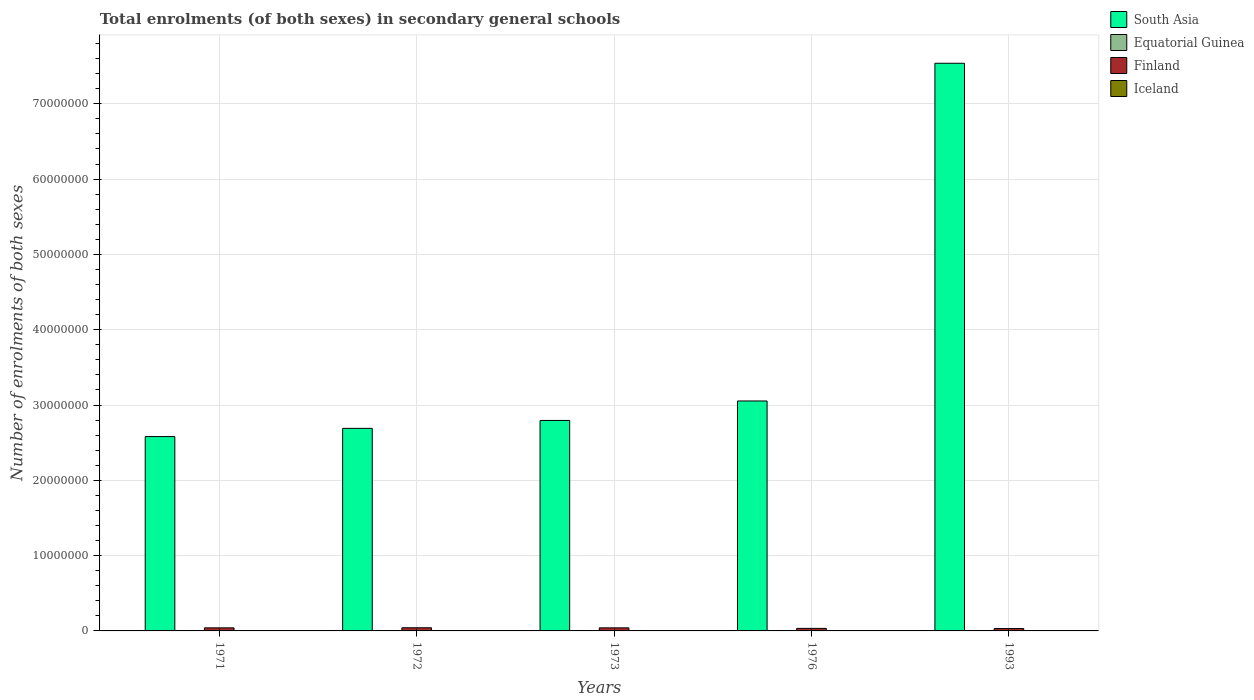How many different coloured bars are there?
Make the answer very short. 4. How many groups of bars are there?
Ensure brevity in your answer.  5. Are the number of bars on each tick of the X-axis equal?
Your response must be concise. Yes. How many bars are there on the 4th tick from the left?
Your response must be concise. 4. How many bars are there on the 2nd tick from the right?
Give a very brief answer. 4. What is the label of the 5th group of bars from the left?
Your answer should be very brief. 1993. What is the number of enrolments in secondary schools in Finland in 1972?
Ensure brevity in your answer.  4.18e+05. Across all years, what is the maximum number of enrolments in secondary schools in Equatorial Guinea?
Offer a terse response. 1.52e+04. Across all years, what is the minimum number of enrolments in secondary schools in Equatorial Guinea?
Give a very brief answer. 3984. What is the total number of enrolments in secondary schools in Finland in the graph?
Provide a succinct answer. 1.89e+06. What is the difference between the number of enrolments in secondary schools in Equatorial Guinea in 1972 and that in 1973?
Offer a very short reply. 188. What is the difference between the number of enrolments in secondary schools in Equatorial Guinea in 1973 and the number of enrolments in secondary schools in Iceland in 1976?
Offer a terse response. -1.56e+04. What is the average number of enrolments in secondary schools in Finland per year?
Provide a succinct answer. 3.77e+05. In the year 1971, what is the difference between the number of enrolments in secondary schools in South Asia and number of enrolments in secondary schools in Iceland?
Ensure brevity in your answer.  2.58e+07. In how many years, is the number of enrolments in secondary schools in Iceland greater than 30000000?
Make the answer very short. 0. What is the ratio of the number of enrolments in secondary schools in Equatorial Guinea in 1976 to that in 1993?
Your answer should be very brief. 0.26. Is the number of enrolments in secondary schools in Equatorial Guinea in 1971 less than that in 1973?
Your answer should be very brief. No. What is the difference between the highest and the second highest number of enrolments in secondary schools in Iceland?
Your answer should be very brief. 4076. What is the difference between the highest and the lowest number of enrolments in secondary schools in Finland?
Keep it short and to the point. 1.03e+05. What does the 2nd bar from the left in 1993 represents?
Make the answer very short. Equatorial Guinea. What does the 3rd bar from the right in 1976 represents?
Provide a short and direct response. Equatorial Guinea. Is it the case that in every year, the sum of the number of enrolments in secondary schools in Finland and number of enrolments in secondary schools in Equatorial Guinea is greater than the number of enrolments in secondary schools in South Asia?
Your answer should be very brief. No. Are the values on the major ticks of Y-axis written in scientific E-notation?
Keep it short and to the point. No. Does the graph contain grids?
Provide a succinct answer. Yes. Where does the legend appear in the graph?
Provide a succinct answer. Top right. How many legend labels are there?
Provide a succinct answer. 4. How are the legend labels stacked?
Keep it short and to the point. Vertical. What is the title of the graph?
Ensure brevity in your answer.  Total enrolments (of both sexes) in secondary general schools. What is the label or title of the X-axis?
Provide a short and direct response. Years. What is the label or title of the Y-axis?
Your answer should be compact. Number of enrolments of both sexes. What is the Number of enrolments of both sexes of South Asia in 1971?
Your answer should be very brief. 2.58e+07. What is the Number of enrolments of both sexes in Equatorial Guinea in 1971?
Ensure brevity in your answer.  5198. What is the Number of enrolments of both sexes of Finland in 1971?
Your answer should be compact. 4.08e+05. What is the Number of enrolments of both sexes in Iceland in 1971?
Keep it short and to the point. 1.81e+04. What is the Number of enrolments of both sexes in South Asia in 1972?
Provide a succinct answer. 2.69e+07. What is the Number of enrolments of both sexes in Equatorial Guinea in 1972?
Your answer should be very brief. 4901. What is the Number of enrolments of both sexes of Finland in 1972?
Your answer should be very brief. 4.18e+05. What is the Number of enrolments of both sexes of Iceland in 1972?
Provide a short and direct response. 1.88e+04. What is the Number of enrolments of both sexes in South Asia in 1973?
Provide a succinct answer. 2.80e+07. What is the Number of enrolments of both sexes in Equatorial Guinea in 1973?
Keep it short and to the point. 4713. What is the Number of enrolments of both sexes of Finland in 1973?
Make the answer very short. 4.08e+05. What is the Number of enrolments of both sexes in Iceland in 1973?
Keep it short and to the point. 1.94e+04. What is the Number of enrolments of both sexes of South Asia in 1976?
Offer a terse response. 3.05e+07. What is the Number of enrolments of both sexes of Equatorial Guinea in 1976?
Provide a succinct answer. 3984. What is the Number of enrolments of both sexes of Finland in 1976?
Offer a very short reply. 3.38e+05. What is the Number of enrolments of both sexes in Iceland in 1976?
Offer a terse response. 2.03e+04. What is the Number of enrolments of both sexes of South Asia in 1993?
Offer a terse response. 7.54e+07. What is the Number of enrolments of both sexes in Equatorial Guinea in 1993?
Give a very brief answer. 1.52e+04. What is the Number of enrolments of both sexes of Finland in 1993?
Offer a very short reply. 3.14e+05. What is the Number of enrolments of both sexes in Iceland in 1993?
Your answer should be very brief. 2.44e+04. Across all years, what is the maximum Number of enrolments of both sexes of South Asia?
Provide a short and direct response. 7.54e+07. Across all years, what is the maximum Number of enrolments of both sexes of Equatorial Guinea?
Your answer should be compact. 1.52e+04. Across all years, what is the maximum Number of enrolments of both sexes of Finland?
Provide a succinct answer. 4.18e+05. Across all years, what is the maximum Number of enrolments of both sexes in Iceland?
Your answer should be compact. 2.44e+04. Across all years, what is the minimum Number of enrolments of both sexes of South Asia?
Your response must be concise. 2.58e+07. Across all years, what is the minimum Number of enrolments of both sexes in Equatorial Guinea?
Provide a short and direct response. 3984. Across all years, what is the minimum Number of enrolments of both sexes of Finland?
Your answer should be compact. 3.14e+05. Across all years, what is the minimum Number of enrolments of both sexes in Iceland?
Ensure brevity in your answer.  1.81e+04. What is the total Number of enrolments of both sexes of South Asia in the graph?
Make the answer very short. 1.87e+08. What is the total Number of enrolments of both sexes of Equatorial Guinea in the graph?
Give a very brief answer. 3.40e+04. What is the total Number of enrolments of both sexes in Finland in the graph?
Provide a short and direct response. 1.89e+06. What is the total Number of enrolments of both sexes in Iceland in the graph?
Provide a short and direct response. 1.01e+05. What is the difference between the Number of enrolments of both sexes of South Asia in 1971 and that in 1972?
Offer a very short reply. -1.09e+06. What is the difference between the Number of enrolments of both sexes in Equatorial Guinea in 1971 and that in 1972?
Give a very brief answer. 297. What is the difference between the Number of enrolments of both sexes of Finland in 1971 and that in 1972?
Your response must be concise. -9545. What is the difference between the Number of enrolments of both sexes in Iceland in 1971 and that in 1972?
Your response must be concise. -749. What is the difference between the Number of enrolments of both sexes of South Asia in 1971 and that in 1973?
Provide a succinct answer. -2.14e+06. What is the difference between the Number of enrolments of both sexes of Equatorial Guinea in 1971 and that in 1973?
Your answer should be very brief. 485. What is the difference between the Number of enrolments of both sexes in Finland in 1971 and that in 1973?
Keep it short and to the point. -486. What is the difference between the Number of enrolments of both sexes in Iceland in 1971 and that in 1973?
Keep it short and to the point. -1308. What is the difference between the Number of enrolments of both sexes in South Asia in 1971 and that in 1976?
Your answer should be very brief. -4.73e+06. What is the difference between the Number of enrolments of both sexes in Equatorial Guinea in 1971 and that in 1976?
Make the answer very short. 1214. What is the difference between the Number of enrolments of both sexes of Finland in 1971 and that in 1976?
Make the answer very short. 7.04e+04. What is the difference between the Number of enrolments of both sexes of Iceland in 1971 and that in 1976?
Provide a short and direct response. -2218. What is the difference between the Number of enrolments of both sexes of South Asia in 1971 and that in 1993?
Keep it short and to the point. -4.96e+07. What is the difference between the Number of enrolments of both sexes in Equatorial Guinea in 1971 and that in 1993?
Provide a short and direct response. -9982. What is the difference between the Number of enrolments of both sexes of Finland in 1971 and that in 1993?
Give a very brief answer. 9.37e+04. What is the difference between the Number of enrolments of both sexes in Iceland in 1971 and that in 1993?
Ensure brevity in your answer.  -6294. What is the difference between the Number of enrolments of both sexes in South Asia in 1972 and that in 1973?
Keep it short and to the point. -1.05e+06. What is the difference between the Number of enrolments of both sexes of Equatorial Guinea in 1972 and that in 1973?
Provide a succinct answer. 188. What is the difference between the Number of enrolments of both sexes in Finland in 1972 and that in 1973?
Provide a short and direct response. 9059. What is the difference between the Number of enrolments of both sexes of Iceland in 1972 and that in 1973?
Provide a short and direct response. -559. What is the difference between the Number of enrolments of both sexes in South Asia in 1972 and that in 1976?
Make the answer very short. -3.64e+06. What is the difference between the Number of enrolments of both sexes of Equatorial Guinea in 1972 and that in 1976?
Make the answer very short. 917. What is the difference between the Number of enrolments of both sexes in Finland in 1972 and that in 1976?
Give a very brief answer. 7.99e+04. What is the difference between the Number of enrolments of both sexes in Iceland in 1972 and that in 1976?
Your answer should be very brief. -1469. What is the difference between the Number of enrolments of both sexes of South Asia in 1972 and that in 1993?
Provide a short and direct response. -4.85e+07. What is the difference between the Number of enrolments of both sexes in Equatorial Guinea in 1972 and that in 1993?
Your answer should be very brief. -1.03e+04. What is the difference between the Number of enrolments of both sexes of Finland in 1972 and that in 1993?
Your answer should be compact. 1.03e+05. What is the difference between the Number of enrolments of both sexes in Iceland in 1972 and that in 1993?
Offer a very short reply. -5545. What is the difference between the Number of enrolments of both sexes of South Asia in 1973 and that in 1976?
Offer a very short reply. -2.59e+06. What is the difference between the Number of enrolments of both sexes in Equatorial Guinea in 1973 and that in 1976?
Offer a terse response. 729. What is the difference between the Number of enrolments of both sexes of Finland in 1973 and that in 1976?
Your answer should be compact. 7.09e+04. What is the difference between the Number of enrolments of both sexes in Iceland in 1973 and that in 1976?
Keep it short and to the point. -910. What is the difference between the Number of enrolments of both sexes in South Asia in 1973 and that in 1993?
Make the answer very short. -4.74e+07. What is the difference between the Number of enrolments of both sexes of Equatorial Guinea in 1973 and that in 1993?
Give a very brief answer. -1.05e+04. What is the difference between the Number of enrolments of both sexes of Finland in 1973 and that in 1993?
Your answer should be compact. 9.42e+04. What is the difference between the Number of enrolments of both sexes in Iceland in 1973 and that in 1993?
Give a very brief answer. -4986. What is the difference between the Number of enrolments of both sexes in South Asia in 1976 and that in 1993?
Give a very brief answer. -4.48e+07. What is the difference between the Number of enrolments of both sexes of Equatorial Guinea in 1976 and that in 1993?
Provide a succinct answer. -1.12e+04. What is the difference between the Number of enrolments of both sexes of Finland in 1976 and that in 1993?
Give a very brief answer. 2.33e+04. What is the difference between the Number of enrolments of both sexes of Iceland in 1976 and that in 1993?
Provide a short and direct response. -4076. What is the difference between the Number of enrolments of both sexes in South Asia in 1971 and the Number of enrolments of both sexes in Equatorial Guinea in 1972?
Ensure brevity in your answer.  2.58e+07. What is the difference between the Number of enrolments of both sexes of South Asia in 1971 and the Number of enrolments of both sexes of Finland in 1972?
Keep it short and to the point. 2.54e+07. What is the difference between the Number of enrolments of both sexes in South Asia in 1971 and the Number of enrolments of both sexes in Iceland in 1972?
Offer a very short reply. 2.58e+07. What is the difference between the Number of enrolments of both sexes of Equatorial Guinea in 1971 and the Number of enrolments of both sexes of Finland in 1972?
Keep it short and to the point. -4.12e+05. What is the difference between the Number of enrolments of both sexes of Equatorial Guinea in 1971 and the Number of enrolments of both sexes of Iceland in 1972?
Offer a very short reply. -1.36e+04. What is the difference between the Number of enrolments of both sexes of Finland in 1971 and the Number of enrolments of both sexes of Iceland in 1972?
Your answer should be compact. 3.89e+05. What is the difference between the Number of enrolments of both sexes of South Asia in 1971 and the Number of enrolments of both sexes of Equatorial Guinea in 1973?
Your answer should be very brief. 2.58e+07. What is the difference between the Number of enrolments of both sexes in South Asia in 1971 and the Number of enrolments of both sexes in Finland in 1973?
Provide a short and direct response. 2.54e+07. What is the difference between the Number of enrolments of both sexes in South Asia in 1971 and the Number of enrolments of both sexes in Iceland in 1973?
Provide a short and direct response. 2.58e+07. What is the difference between the Number of enrolments of both sexes of Equatorial Guinea in 1971 and the Number of enrolments of both sexes of Finland in 1973?
Your answer should be compact. -4.03e+05. What is the difference between the Number of enrolments of both sexes of Equatorial Guinea in 1971 and the Number of enrolments of both sexes of Iceland in 1973?
Make the answer very short. -1.42e+04. What is the difference between the Number of enrolments of both sexes of Finland in 1971 and the Number of enrolments of both sexes of Iceland in 1973?
Make the answer very short. 3.89e+05. What is the difference between the Number of enrolments of both sexes in South Asia in 1971 and the Number of enrolments of both sexes in Equatorial Guinea in 1976?
Ensure brevity in your answer.  2.58e+07. What is the difference between the Number of enrolments of both sexes in South Asia in 1971 and the Number of enrolments of both sexes in Finland in 1976?
Give a very brief answer. 2.55e+07. What is the difference between the Number of enrolments of both sexes in South Asia in 1971 and the Number of enrolments of both sexes in Iceland in 1976?
Make the answer very short. 2.58e+07. What is the difference between the Number of enrolments of both sexes in Equatorial Guinea in 1971 and the Number of enrolments of both sexes in Finland in 1976?
Offer a very short reply. -3.32e+05. What is the difference between the Number of enrolments of both sexes of Equatorial Guinea in 1971 and the Number of enrolments of both sexes of Iceland in 1976?
Your answer should be compact. -1.51e+04. What is the difference between the Number of enrolments of both sexes in Finland in 1971 and the Number of enrolments of both sexes in Iceland in 1976?
Your answer should be very brief. 3.88e+05. What is the difference between the Number of enrolments of both sexes of South Asia in 1971 and the Number of enrolments of both sexes of Equatorial Guinea in 1993?
Your answer should be very brief. 2.58e+07. What is the difference between the Number of enrolments of both sexes of South Asia in 1971 and the Number of enrolments of both sexes of Finland in 1993?
Ensure brevity in your answer.  2.55e+07. What is the difference between the Number of enrolments of both sexes of South Asia in 1971 and the Number of enrolments of both sexes of Iceland in 1993?
Provide a short and direct response. 2.58e+07. What is the difference between the Number of enrolments of both sexes in Equatorial Guinea in 1971 and the Number of enrolments of both sexes in Finland in 1993?
Provide a short and direct response. -3.09e+05. What is the difference between the Number of enrolments of both sexes of Equatorial Guinea in 1971 and the Number of enrolments of both sexes of Iceland in 1993?
Give a very brief answer. -1.92e+04. What is the difference between the Number of enrolments of both sexes of Finland in 1971 and the Number of enrolments of both sexes of Iceland in 1993?
Make the answer very short. 3.84e+05. What is the difference between the Number of enrolments of both sexes in South Asia in 1972 and the Number of enrolments of both sexes in Equatorial Guinea in 1973?
Your answer should be very brief. 2.69e+07. What is the difference between the Number of enrolments of both sexes in South Asia in 1972 and the Number of enrolments of both sexes in Finland in 1973?
Give a very brief answer. 2.65e+07. What is the difference between the Number of enrolments of both sexes of South Asia in 1972 and the Number of enrolments of both sexes of Iceland in 1973?
Ensure brevity in your answer.  2.69e+07. What is the difference between the Number of enrolments of both sexes in Equatorial Guinea in 1972 and the Number of enrolments of both sexes in Finland in 1973?
Your answer should be compact. -4.04e+05. What is the difference between the Number of enrolments of both sexes of Equatorial Guinea in 1972 and the Number of enrolments of both sexes of Iceland in 1973?
Offer a very short reply. -1.45e+04. What is the difference between the Number of enrolments of both sexes in Finland in 1972 and the Number of enrolments of both sexes in Iceland in 1973?
Your response must be concise. 3.98e+05. What is the difference between the Number of enrolments of both sexes in South Asia in 1972 and the Number of enrolments of both sexes in Equatorial Guinea in 1976?
Offer a very short reply. 2.69e+07. What is the difference between the Number of enrolments of both sexes in South Asia in 1972 and the Number of enrolments of both sexes in Finland in 1976?
Offer a very short reply. 2.66e+07. What is the difference between the Number of enrolments of both sexes in South Asia in 1972 and the Number of enrolments of both sexes in Iceland in 1976?
Provide a succinct answer. 2.69e+07. What is the difference between the Number of enrolments of both sexes of Equatorial Guinea in 1972 and the Number of enrolments of both sexes of Finland in 1976?
Provide a short and direct response. -3.33e+05. What is the difference between the Number of enrolments of both sexes in Equatorial Guinea in 1972 and the Number of enrolments of both sexes in Iceland in 1976?
Your response must be concise. -1.54e+04. What is the difference between the Number of enrolments of both sexes of Finland in 1972 and the Number of enrolments of both sexes of Iceland in 1976?
Offer a terse response. 3.97e+05. What is the difference between the Number of enrolments of both sexes in South Asia in 1972 and the Number of enrolments of both sexes in Equatorial Guinea in 1993?
Your answer should be compact. 2.69e+07. What is the difference between the Number of enrolments of both sexes in South Asia in 1972 and the Number of enrolments of both sexes in Finland in 1993?
Offer a terse response. 2.66e+07. What is the difference between the Number of enrolments of both sexes of South Asia in 1972 and the Number of enrolments of both sexes of Iceland in 1993?
Your response must be concise. 2.69e+07. What is the difference between the Number of enrolments of both sexes of Equatorial Guinea in 1972 and the Number of enrolments of both sexes of Finland in 1993?
Offer a very short reply. -3.09e+05. What is the difference between the Number of enrolments of both sexes of Equatorial Guinea in 1972 and the Number of enrolments of both sexes of Iceland in 1993?
Ensure brevity in your answer.  -1.95e+04. What is the difference between the Number of enrolments of both sexes in Finland in 1972 and the Number of enrolments of both sexes in Iceland in 1993?
Offer a terse response. 3.93e+05. What is the difference between the Number of enrolments of both sexes of South Asia in 1973 and the Number of enrolments of both sexes of Equatorial Guinea in 1976?
Give a very brief answer. 2.79e+07. What is the difference between the Number of enrolments of both sexes in South Asia in 1973 and the Number of enrolments of both sexes in Finland in 1976?
Ensure brevity in your answer.  2.76e+07. What is the difference between the Number of enrolments of both sexes of South Asia in 1973 and the Number of enrolments of both sexes of Iceland in 1976?
Your answer should be very brief. 2.79e+07. What is the difference between the Number of enrolments of both sexes in Equatorial Guinea in 1973 and the Number of enrolments of both sexes in Finland in 1976?
Your response must be concise. -3.33e+05. What is the difference between the Number of enrolments of both sexes in Equatorial Guinea in 1973 and the Number of enrolments of both sexes in Iceland in 1976?
Offer a terse response. -1.56e+04. What is the difference between the Number of enrolments of both sexes in Finland in 1973 and the Number of enrolments of both sexes in Iceland in 1976?
Offer a very short reply. 3.88e+05. What is the difference between the Number of enrolments of both sexes of South Asia in 1973 and the Number of enrolments of both sexes of Equatorial Guinea in 1993?
Your answer should be very brief. 2.79e+07. What is the difference between the Number of enrolments of both sexes of South Asia in 1973 and the Number of enrolments of both sexes of Finland in 1993?
Keep it short and to the point. 2.76e+07. What is the difference between the Number of enrolments of both sexes in South Asia in 1973 and the Number of enrolments of both sexes in Iceland in 1993?
Keep it short and to the point. 2.79e+07. What is the difference between the Number of enrolments of both sexes in Equatorial Guinea in 1973 and the Number of enrolments of both sexes in Finland in 1993?
Offer a very short reply. -3.10e+05. What is the difference between the Number of enrolments of both sexes in Equatorial Guinea in 1973 and the Number of enrolments of both sexes in Iceland in 1993?
Give a very brief answer. -1.97e+04. What is the difference between the Number of enrolments of both sexes in Finland in 1973 and the Number of enrolments of both sexes in Iceland in 1993?
Ensure brevity in your answer.  3.84e+05. What is the difference between the Number of enrolments of both sexes of South Asia in 1976 and the Number of enrolments of both sexes of Equatorial Guinea in 1993?
Offer a very short reply. 3.05e+07. What is the difference between the Number of enrolments of both sexes of South Asia in 1976 and the Number of enrolments of both sexes of Finland in 1993?
Make the answer very short. 3.02e+07. What is the difference between the Number of enrolments of both sexes of South Asia in 1976 and the Number of enrolments of both sexes of Iceland in 1993?
Your answer should be very brief. 3.05e+07. What is the difference between the Number of enrolments of both sexes of Equatorial Guinea in 1976 and the Number of enrolments of both sexes of Finland in 1993?
Make the answer very short. -3.10e+05. What is the difference between the Number of enrolments of both sexes in Equatorial Guinea in 1976 and the Number of enrolments of both sexes in Iceland in 1993?
Make the answer very short. -2.04e+04. What is the difference between the Number of enrolments of both sexes of Finland in 1976 and the Number of enrolments of both sexes of Iceland in 1993?
Offer a very short reply. 3.13e+05. What is the average Number of enrolments of both sexes in South Asia per year?
Your answer should be very brief. 3.73e+07. What is the average Number of enrolments of both sexes of Equatorial Guinea per year?
Ensure brevity in your answer.  6795.2. What is the average Number of enrolments of both sexes of Finland per year?
Make the answer very short. 3.77e+05. What is the average Number of enrolments of both sexes of Iceland per year?
Keep it short and to the point. 2.02e+04. In the year 1971, what is the difference between the Number of enrolments of both sexes in South Asia and Number of enrolments of both sexes in Equatorial Guinea?
Your answer should be compact. 2.58e+07. In the year 1971, what is the difference between the Number of enrolments of both sexes in South Asia and Number of enrolments of both sexes in Finland?
Make the answer very short. 2.54e+07. In the year 1971, what is the difference between the Number of enrolments of both sexes in South Asia and Number of enrolments of both sexes in Iceland?
Your answer should be very brief. 2.58e+07. In the year 1971, what is the difference between the Number of enrolments of both sexes of Equatorial Guinea and Number of enrolments of both sexes of Finland?
Make the answer very short. -4.03e+05. In the year 1971, what is the difference between the Number of enrolments of both sexes in Equatorial Guinea and Number of enrolments of both sexes in Iceland?
Ensure brevity in your answer.  -1.29e+04. In the year 1971, what is the difference between the Number of enrolments of both sexes of Finland and Number of enrolments of both sexes of Iceland?
Your response must be concise. 3.90e+05. In the year 1972, what is the difference between the Number of enrolments of both sexes in South Asia and Number of enrolments of both sexes in Equatorial Guinea?
Provide a succinct answer. 2.69e+07. In the year 1972, what is the difference between the Number of enrolments of both sexes of South Asia and Number of enrolments of both sexes of Finland?
Offer a very short reply. 2.65e+07. In the year 1972, what is the difference between the Number of enrolments of both sexes of South Asia and Number of enrolments of both sexes of Iceland?
Your answer should be compact. 2.69e+07. In the year 1972, what is the difference between the Number of enrolments of both sexes of Equatorial Guinea and Number of enrolments of both sexes of Finland?
Keep it short and to the point. -4.13e+05. In the year 1972, what is the difference between the Number of enrolments of both sexes in Equatorial Guinea and Number of enrolments of both sexes in Iceland?
Keep it short and to the point. -1.39e+04. In the year 1972, what is the difference between the Number of enrolments of both sexes in Finland and Number of enrolments of both sexes in Iceland?
Ensure brevity in your answer.  3.99e+05. In the year 1973, what is the difference between the Number of enrolments of both sexes in South Asia and Number of enrolments of both sexes in Equatorial Guinea?
Provide a succinct answer. 2.79e+07. In the year 1973, what is the difference between the Number of enrolments of both sexes of South Asia and Number of enrolments of both sexes of Finland?
Your answer should be very brief. 2.75e+07. In the year 1973, what is the difference between the Number of enrolments of both sexes in South Asia and Number of enrolments of both sexes in Iceland?
Keep it short and to the point. 2.79e+07. In the year 1973, what is the difference between the Number of enrolments of both sexes of Equatorial Guinea and Number of enrolments of both sexes of Finland?
Ensure brevity in your answer.  -4.04e+05. In the year 1973, what is the difference between the Number of enrolments of both sexes of Equatorial Guinea and Number of enrolments of both sexes of Iceland?
Give a very brief answer. -1.47e+04. In the year 1973, what is the difference between the Number of enrolments of both sexes in Finland and Number of enrolments of both sexes in Iceland?
Your answer should be very brief. 3.89e+05. In the year 1976, what is the difference between the Number of enrolments of both sexes of South Asia and Number of enrolments of both sexes of Equatorial Guinea?
Keep it short and to the point. 3.05e+07. In the year 1976, what is the difference between the Number of enrolments of both sexes in South Asia and Number of enrolments of both sexes in Finland?
Provide a succinct answer. 3.02e+07. In the year 1976, what is the difference between the Number of enrolments of both sexes of South Asia and Number of enrolments of both sexes of Iceland?
Your answer should be very brief. 3.05e+07. In the year 1976, what is the difference between the Number of enrolments of both sexes in Equatorial Guinea and Number of enrolments of both sexes in Finland?
Provide a short and direct response. -3.34e+05. In the year 1976, what is the difference between the Number of enrolments of both sexes in Equatorial Guinea and Number of enrolments of both sexes in Iceland?
Ensure brevity in your answer.  -1.63e+04. In the year 1976, what is the difference between the Number of enrolments of both sexes in Finland and Number of enrolments of both sexes in Iceland?
Make the answer very short. 3.17e+05. In the year 1993, what is the difference between the Number of enrolments of both sexes of South Asia and Number of enrolments of both sexes of Equatorial Guinea?
Offer a terse response. 7.54e+07. In the year 1993, what is the difference between the Number of enrolments of both sexes in South Asia and Number of enrolments of both sexes in Finland?
Give a very brief answer. 7.51e+07. In the year 1993, what is the difference between the Number of enrolments of both sexes in South Asia and Number of enrolments of both sexes in Iceland?
Provide a succinct answer. 7.54e+07. In the year 1993, what is the difference between the Number of enrolments of both sexes of Equatorial Guinea and Number of enrolments of both sexes of Finland?
Make the answer very short. -2.99e+05. In the year 1993, what is the difference between the Number of enrolments of both sexes in Equatorial Guinea and Number of enrolments of both sexes in Iceland?
Your response must be concise. -9188. In the year 1993, what is the difference between the Number of enrolments of both sexes in Finland and Number of enrolments of both sexes in Iceland?
Give a very brief answer. 2.90e+05. What is the ratio of the Number of enrolments of both sexes in South Asia in 1971 to that in 1972?
Your response must be concise. 0.96. What is the ratio of the Number of enrolments of both sexes of Equatorial Guinea in 1971 to that in 1972?
Your response must be concise. 1.06. What is the ratio of the Number of enrolments of both sexes in Finland in 1971 to that in 1972?
Provide a short and direct response. 0.98. What is the ratio of the Number of enrolments of both sexes in Iceland in 1971 to that in 1972?
Give a very brief answer. 0.96. What is the ratio of the Number of enrolments of both sexes in South Asia in 1971 to that in 1973?
Give a very brief answer. 0.92. What is the ratio of the Number of enrolments of both sexes in Equatorial Guinea in 1971 to that in 1973?
Your response must be concise. 1.1. What is the ratio of the Number of enrolments of both sexes of Finland in 1971 to that in 1973?
Provide a succinct answer. 1. What is the ratio of the Number of enrolments of both sexes in Iceland in 1971 to that in 1973?
Ensure brevity in your answer.  0.93. What is the ratio of the Number of enrolments of both sexes in South Asia in 1971 to that in 1976?
Offer a very short reply. 0.85. What is the ratio of the Number of enrolments of both sexes in Equatorial Guinea in 1971 to that in 1976?
Your answer should be compact. 1.3. What is the ratio of the Number of enrolments of both sexes in Finland in 1971 to that in 1976?
Give a very brief answer. 1.21. What is the ratio of the Number of enrolments of both sexes of Iceland in 1971 to that in 1976?
Offer a very short reply. 0.89. What is the ratio of the Number of enrolments of both sexes in South Asia in 1971 to that in 1993?
Provide a short and direct response. 0.34. What is the ratio of the Number of enrolments of both sexes in Equatorial Guinea in 1971 to that in 1993?
Your answer should be very brief. 0.34. What is the ratio of the Number of enrolments of both sexes of Finland in 1971 to that in 1993?
Provide a short and direct response. 1.3. What is the ratio of the Number of enrolments of both sexes of Iceland in 1971 to that in 1993?
Your answer should be compact. 0.74. What is the ratio of the Number of enrolments of both sexes of South Asia in 1972 to that in 1973?
Ensure brevity in your answer.  0.96. What is the ratio of the Number of enrolments of both sexes of Equatorial Guinea in 1972 to that in 1973?
Offer a very short reply. 1.04. What is the ratio of the Number of enrolments of both sexes of Finland in 1972 to that in 1973?
Your answer should be compact. 1.02. What is the ratio of the Number of enrolments of both sexes of Iceland in 1972 to that in 1973?
Keep it short and to the point. 0.97. What is the ratio of the Number of enrolments of both sexes in South Asia in 1972 to that in 1976?
Offer a terse response. 0.88. What is the ratio of the Number of enrolments of both sexes of Equatorial Guinea in 1972 to that in 1976?
Make the answer very short. 1.23. What is the ratio of the Number of enrolments of both sexes in Finland in 1972 to that in 1976?
Offer a terse response. 1.24. What is the ratio of the Number of enrolments of both sexes of Iceland in 1972 to that in 1976?
Offer a very short reply. 0.93. What is the ratio of the Number of enrolments of both sexes in South Asia in 1972 to that in 1993?
Your answer should be compact. 0.36. What is the ratio of the Number of enrolments of both sexes in Equatorial Guinea in 1972 to that in 1993?
Provide a short and direct response. 0.32. What is the ratio of the Number of enrolments of both sexes of Finland in 1972 to that in 1993?
Provide a short and direct response. 1.33. What is the ratio of the Number of enrolments of both sexes in Iceland in 1972 to that in 1993?
Your answer should be very brief. 0.77. What is the ratio of the Number of enrolments of both sexes in South Asia in 1973 to that in 1976?
Make the answer very short. 0.92. What is the ratio of the Number of enrolments of both sexes in Equatorial Guinea in 1973 to that in 1976?
Give a very brief answer. 1.18. What is the ratio of the Number of enrolments of both sexes of Finland in 1973 to that in 1976?
Your answer should be very brief. 1.21. What is the ratio of the Number of enrolments of both sexes in Iceland in 1973 to that in 1976?
Provide a short and direct response. 0.96. What is the ratio of the Number of enrolments of both sexes in South Asia in 1973 to that in 1993?
Provide a succinct answer. 0.37. What is the ratio of the Number of enrolments of both sexes in Equatorial Guinea in 1973 to that in 1993?
Your response must be concise. 0.31. What is the ratio of the Number of enrolments of both sexes in Finland in 1973 to that in 1993?
Your response must be concise. 1.3. What is the ratio of the Number of enrolments of both sexes of Iceland in 1973 to that in 1993?
Offer a terse response. 0.8. What is the ratio of the Number of enrolments of both sexes in South Asia in 1976 to that in 1993?
Offer a terse response. 0.41. What is the ratio of the Number of enrolments of both sexes of Equatorial Guinea in 1976 to that in 1993?
Make the answer very short. 0.26. What is the ratio of the Number of enrolments of both sexes in Finland in 1976 to that in 1993?
Provide a short and direct response. 1.07. What is the ratio of the Number of enrolments of both sexes in Iceland in 1976 to that in 1993?
Make the answer very short. 0.83. What is the difference between the highest and the second highest Number of enrolments of both sexes of South Asia?
Make the answer very short. 4.48e+07. What is the difference between the highest and the second highest Number of enrolments of both sexes in Equatorial Guinea?
Offer a very short reply. 9982. What is the difference between the highest and the second highest Number of enrolments of both sexes of Finland?
Provide a succinct answer. 9059. What is the difference between the highest and the second highest Number of enrolments of both sexes in Iceland?
Provide a succinct answer. 4076. What is the difference between the highest and the lowest Number of enrolments of both sexes of South Asia?
Offer a terse response. 4.96e+07. What is the difference between the highest and the lowest Number of enrolments of both sexes of Equatorial Guinea?
Offer a very short reply. 1.12e+04. What is the difference between the highest and the lowest Number of enrolments of both sexes of Finland?
Keep it short and to the point. 1.03e+05. What is the difference between the highest and the lowest Number of enrolments of both sexes of Iceland?
Make the answer very short. 6294. 